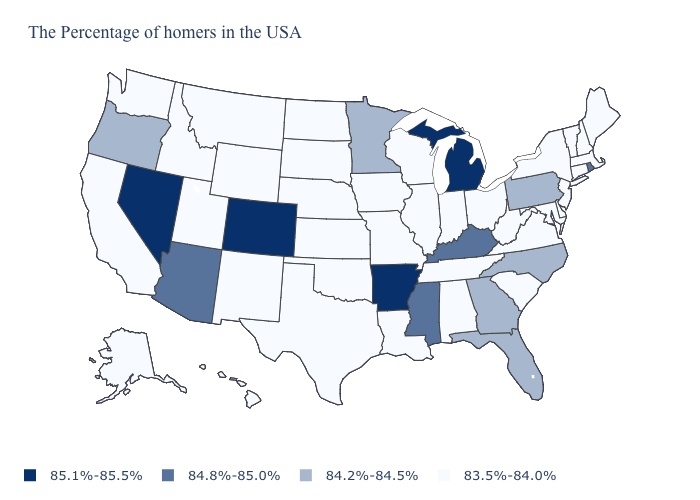What is the value of Mississippi?
Give a very brief answer. 84.8%-85.0%. Name the states that have a value in the range 84.2%-84.5%?
Answer briefly. Pennsylvania, North Carolina, Florida, Georgia, Minnesota, Oregon. Name the states that have a value in the range 83.5%-84.0%?
Short answer required. Maine, Massachusetts, New Hampshire, Vermont, Connecticut, New York, New Jersey, Delaware, Maryland, Virginia, South Carolina, West Virginia, Ohio, Indiana, Alabama, Tennessee, Wisconsin, Illinois, Louisiana, Missouri, Iowa, Kansas, Nebraska, Oklahoma, Texas, South Dakota, North Dakota, Wyoming, New Mexico, Utah, Montana, Idaho, California, Washington, Alaska, Hawaii. Name the states that have a value in the range 84.2%-84.5%?
Write a very short answer. Pennsylvania, North Carolina, Florida, Georgia, Minnesota, Oregon. What is the value of Delaware?
Be succinct. 83.5%-84.0%. Does the first symbol in the legend represent the smallest category?
Be succinct. No. Does Indiana have a lower value than Georgia?
Quick response, please. Yes. What is the lowest value in states that border Maine?
Answer briefly. 83.5%-84.0%. What is the highest value in the West ?
Answer briefly. 85.1%-85.5%. Does the map have missing data?
Be succinct. No. Name the states that have a value in the range 84.2%-84.5%?
Quick response, please. Pennsylvania, North Carolina, Florida, Georgia, Minnesota, Oregon. Does Michigan have the lowest value in the MidWest?
Write a very short answer. No. What is the value of Oklahoma?
Quick response, please. 83.5%-84.0%. Name the states that have a value in the range 84.8%-85.0%?
Answer briefly. Rhode Island, Kentucky, Mississippi, Arizona. Does the first symbol in the legend represent the smallest category?
Answer briefly. No. 